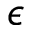Convert formula to latex. <formula><loc_0><loc_0><loc_500><loc_500>\epsilon</formula> 